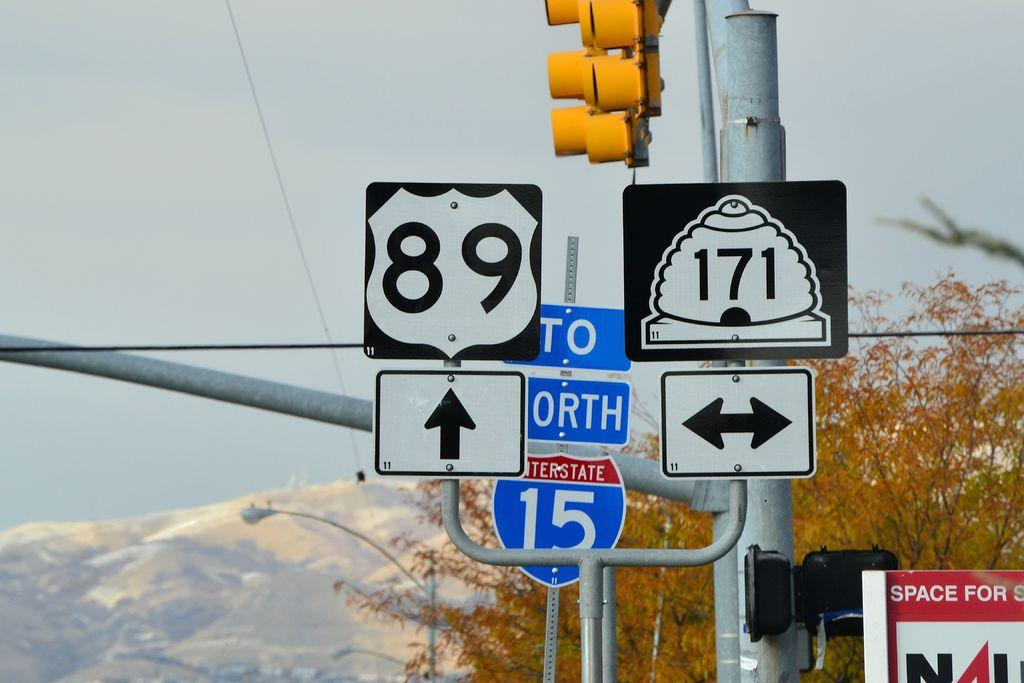<image>
Give a short and clear explanation of the subsequent image. Road signs that read 89 and 171 sit on a traffic light 